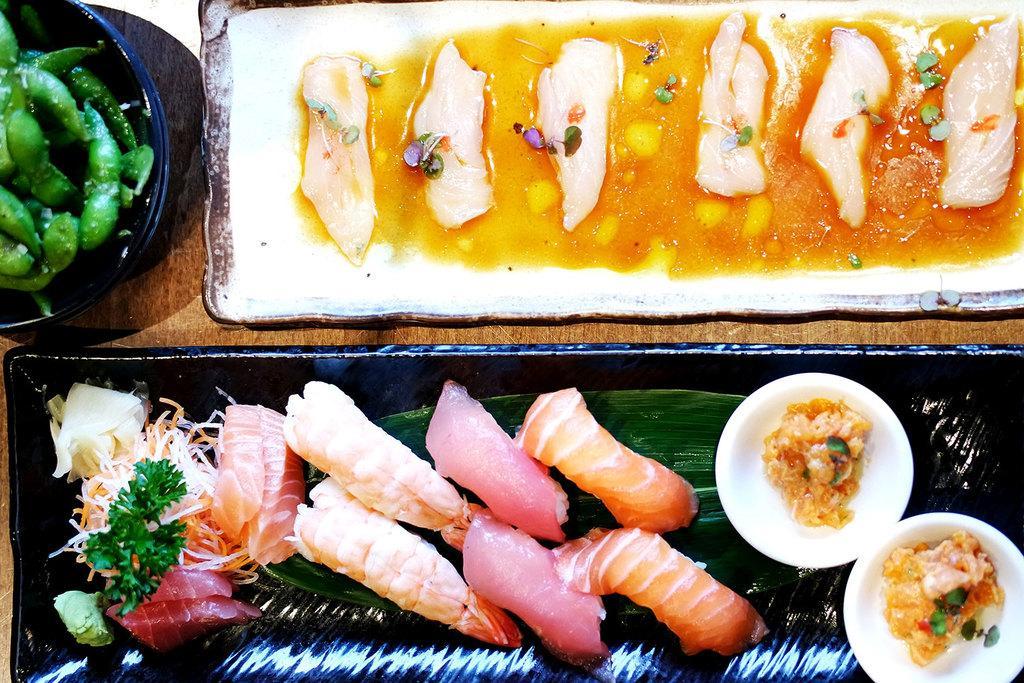What type of food is present in the trays in the image? There are two trays containing meat in the image. What other types of food can be seen in the image? There are bowls containing food in the image. Can you describe the black bowl in the image? The black bowl in the image contains peas. What is the color of the table in the image? The table in the image is brown in color. How many cushions are on the table in the image? There are no cushions present on the table in the image. What type of health benefits can be gained from eating the meat in the image? The image does not provide information about the health benefits of the meat, and it is not our role to make assumptions about such matters. 